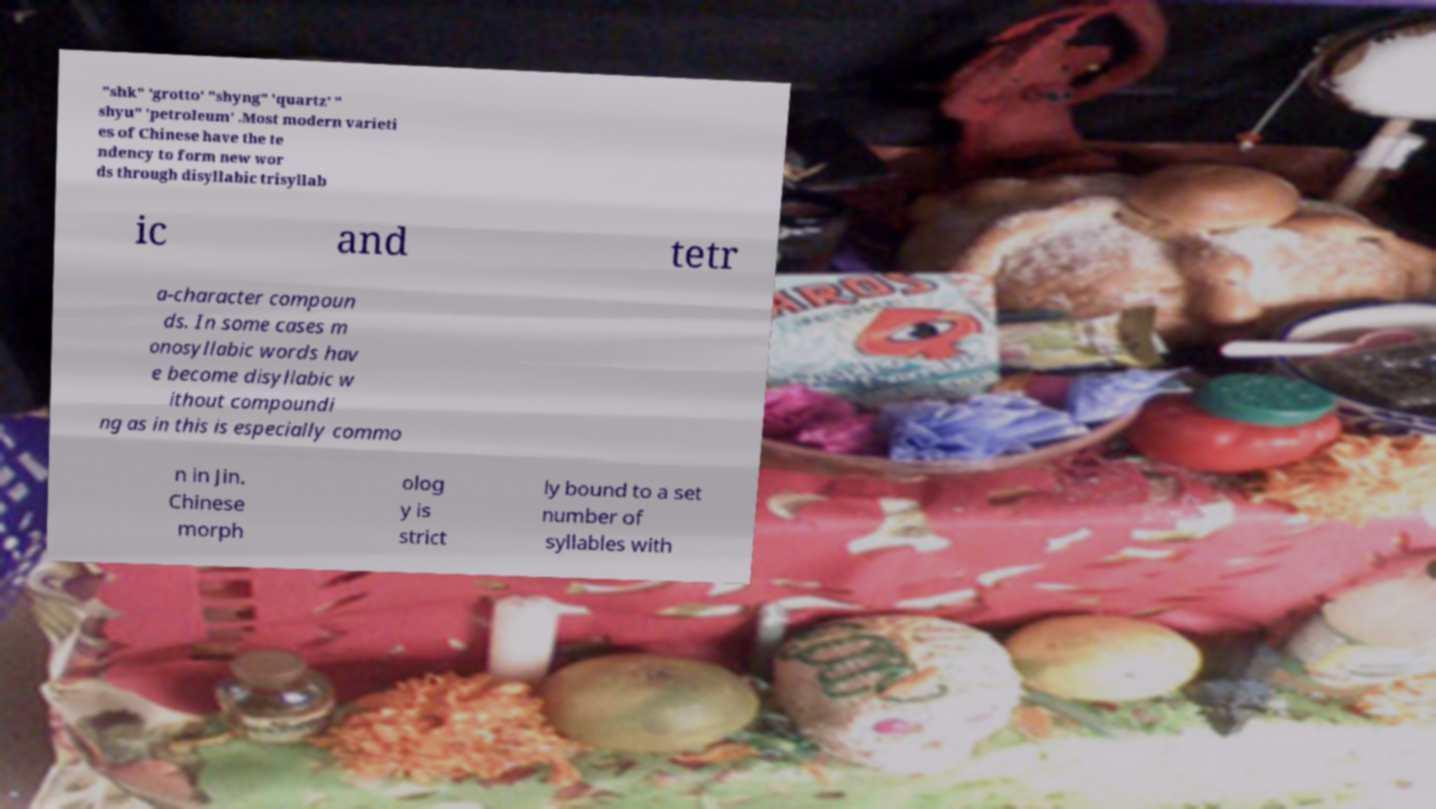Could you assist in decoding the text presented in this image and type it out clearly? "shk" 'grotto' "shyng" 'quartz' " shyu" 'petroleum' .Most modern varieti es of Chinese have the te ndency to form new wor ds through disyllabic trisyllab ic and tetr a-character compoun ds. In some cases m onosyllabic words hav e become disyllabic w ithout compoundi ng as in this is especially commo n in Jin. Chinese morph olog y is strict ly bound to a set number of syllables with 